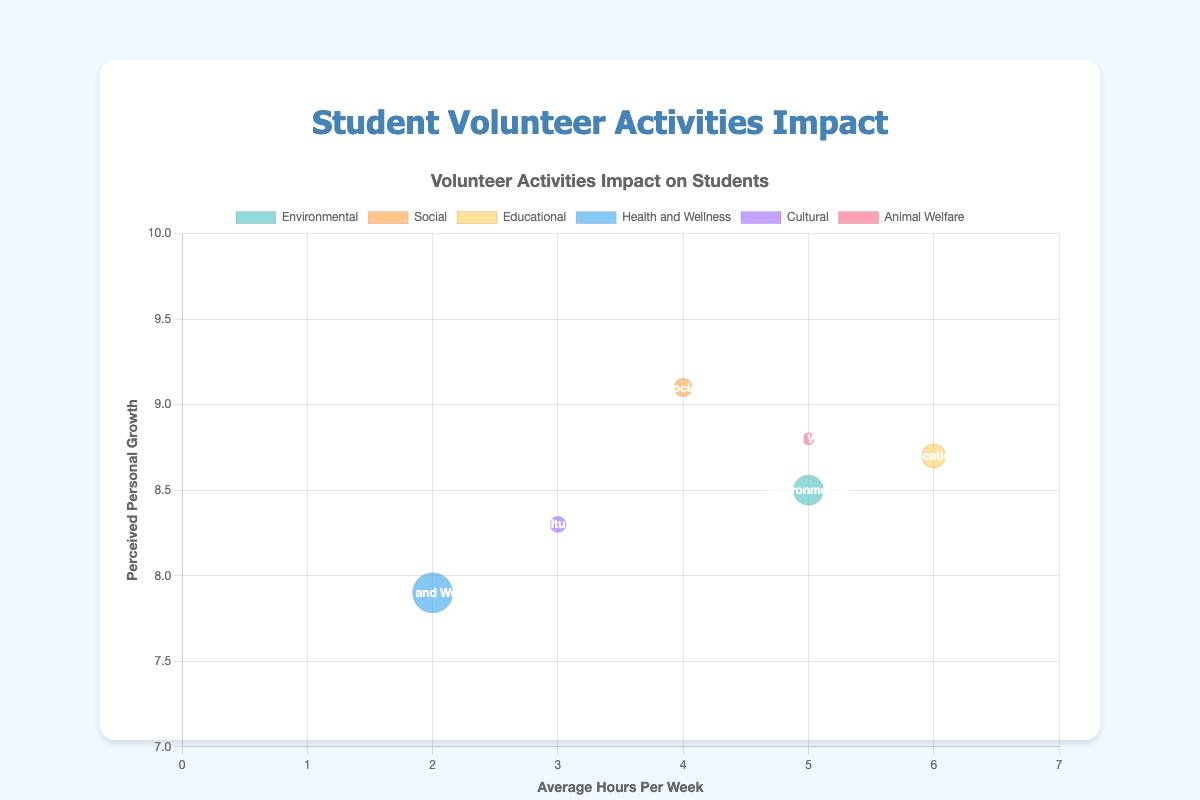What's the title of the chart? The title of the chart is clearly mentioned at the top.
Answer: Volunteer Activities Impact on Students Which activity has the highest perceived personal growth? By looking at the y-axis, the highest data point corresponds to "Visit Senior Homes" under the Social category with a y-value of 9.1.
Answer: Visit Senior Homes How many activities have an average of 5 hours per week? Identify the data points on the x-axis at x=5, which are "Clean the Beach" and "Animal Shelter Volunteering".
Answer: 2 Which activity has the largest number of participants? The largest bubble represents the highest number, which corresponds to the "Campus Blood Drive" in Health and Wellness with a radius of 20.
Answer: Campus Blood Drive What is the perceived personal growth for the activity with the most hours per week? Locate the data point with the highest x-value, "Tutoring Program" (x=6, y=8.7), which corresponds to the Educational category.
Answer: 8.7 What's the sum of average hours per week for all activities? Add the x-values of all datasets: 5 (Clean the Beach) + 4 (Visit Senior Homes) + 6 (Tutoring Program) + 2 (Campus Blood Drive) + 3 (Local Heritage Festival) + 5 (Animal Shelter Volunteering) = 25.
Answer: 25 Which two activities have the same average hours per week and how do their perceived personal growth compare? Both "Clean the Beach" and "Animal Shelter Volunteering" have an average of 5 hours per week. Their perceived personal growth values are 8.5 and 8.8, respectively.
Answer: Clean the Beach and Animal Shelter Volunteering; 8.5 and 8.8 Which activity type has the least number of participants and what is its perceived personal growth? The smallest bubble represents the least number of participants, corresponding to "Animal Shelter Volunteering" under Animal Welfare with a radius of 6, and its y-value for perceived personal growth is 8.8.
Answer: Animal Welfare (Animal Shelter Volunteering); 8.8 